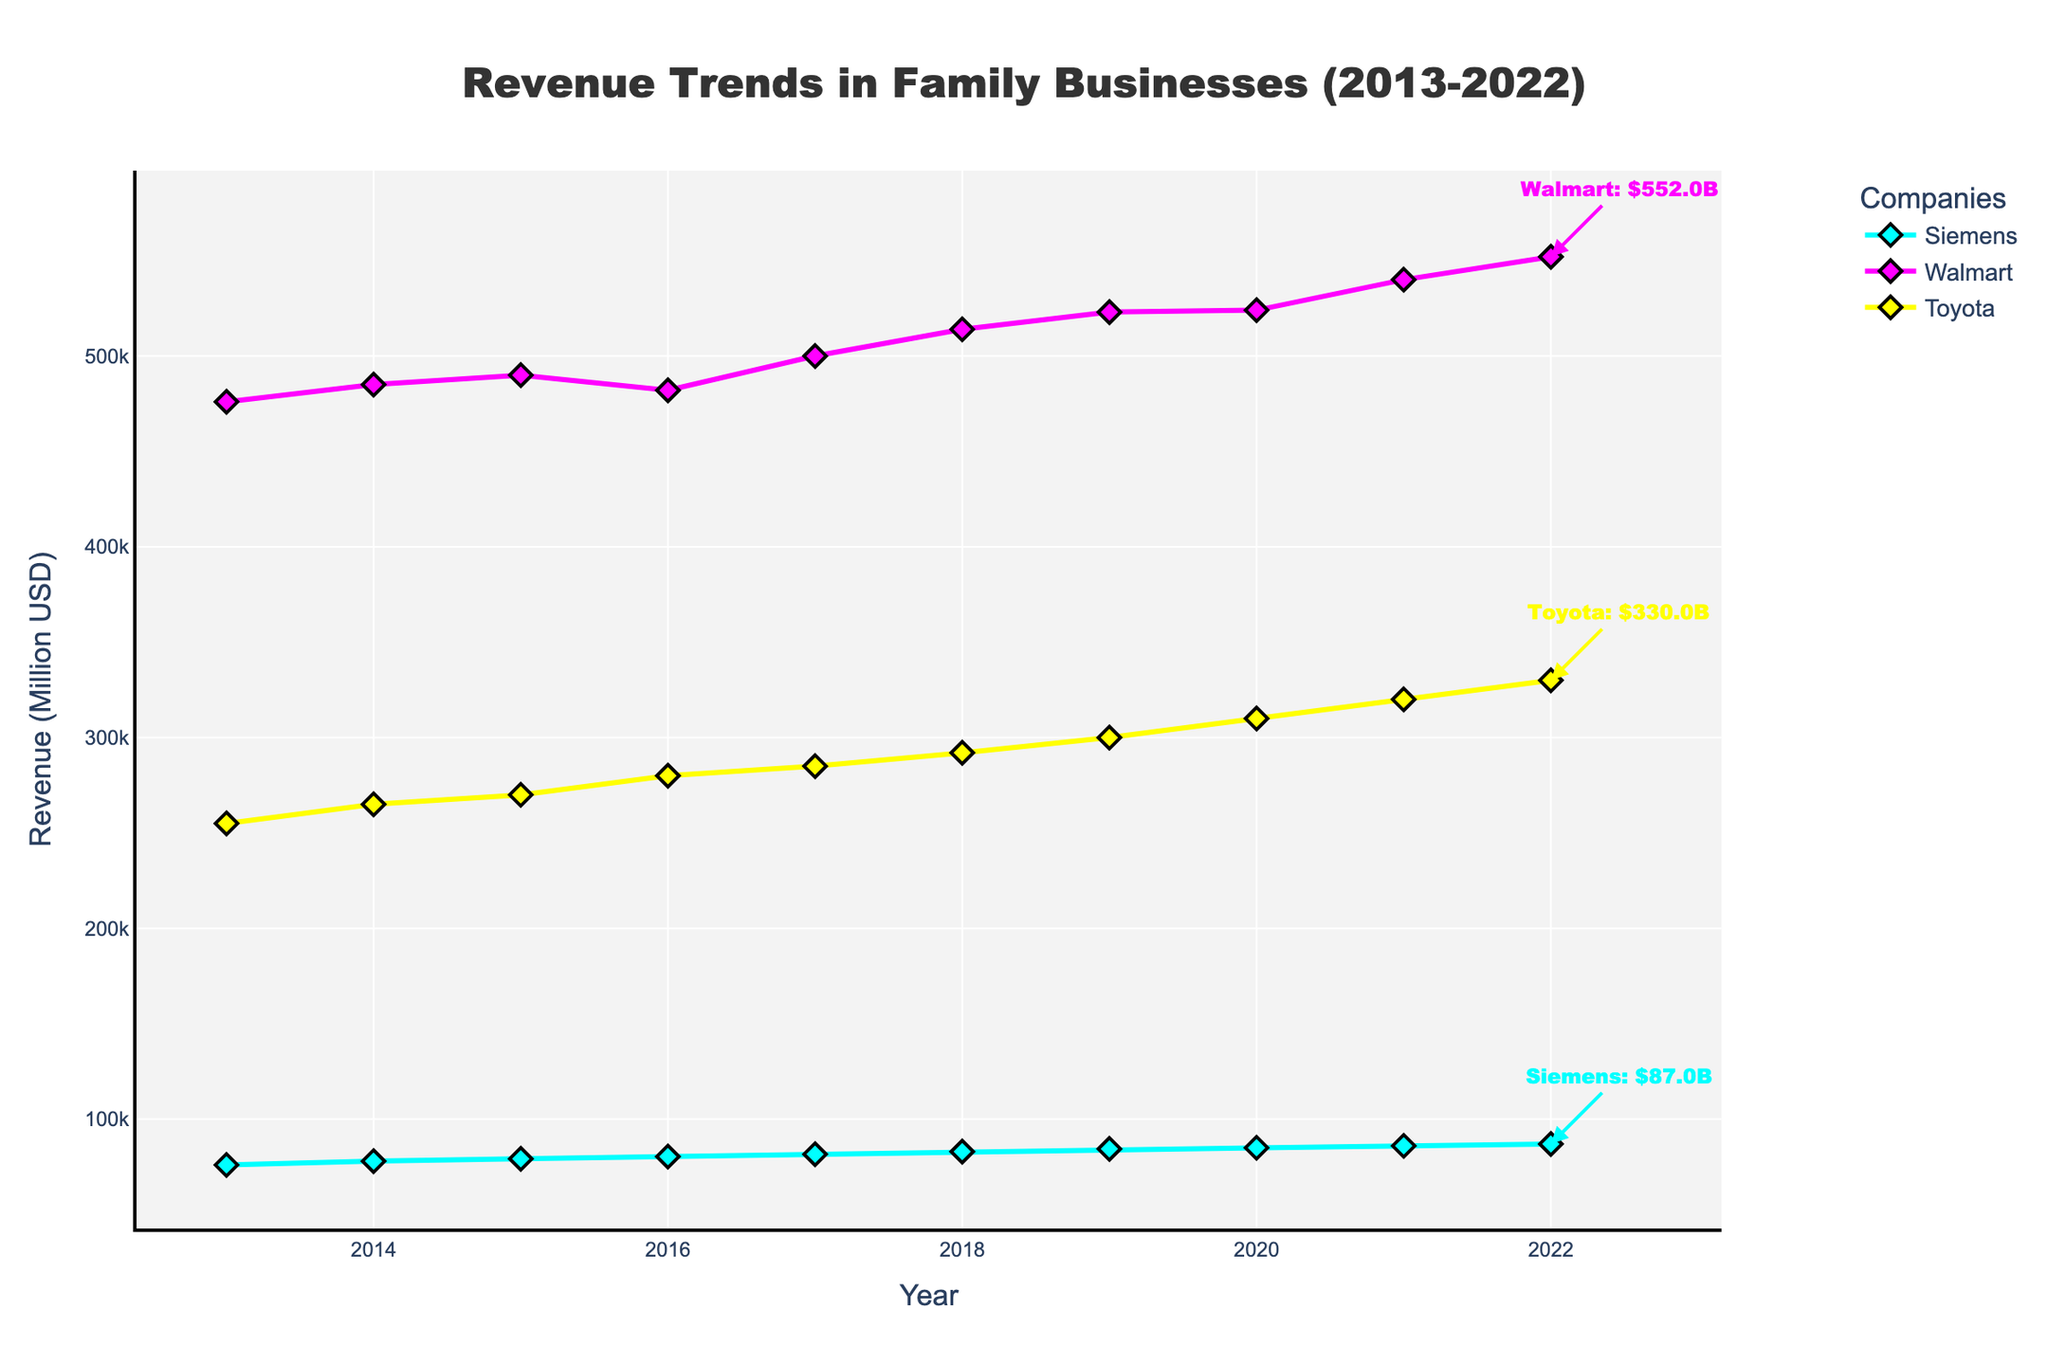What is the title of the plot? The title of the plot is written prominently at the top of the figure.
Answer: Revenue Trends in Family Businesses (2013-2022) Which company in the Manufacturing industry is represented in the plot? The plot uses color coding for different companies, and the annotation shows "Siemens" with revenue values linked to the corresponding color.
Answer: Siemens How many companies' data are included in the plot? By looking at the legend and the different lines on the plot, we can see three companies are represented.
Answer: 3 What was the revenue of Walmart in 2015? Locate the data point along the curve for Walmart at the year 2015 on the x-axis; the corresponding y-value gives the revenue.
Answer: $490,000 million Which company had the highest revenue in 2022? Compare the annotations or the endpoints of the lines at 2022; Walmart has the highest revenue.
Answer: Walmart How did Siemens' revenue change from 2013 to 2022? By looking at Siemens' line from 2013 to 2022, you can see it gradually increases. Calculate the difference between the 2022 and 2013 values: 87000 - 76000 = 11000.
Answer: Increased by $11,000 million Which company experienced the largest revenue growth between 2013 and 2022? Calculate the difference in revenue for each company from 2013 to 2022:
- Siemens: 87000 - 76000 = 11000
- Walmart: 552000 - 476000 = 76000
- Toyota: 330000 - 255000 = 75000
Walmart shows the largest increase.
Answer: Walmart Did any company have a year where its revenue decreased from the previous year? Identify points where the line for a company drops from one year to the next. For Walmart, there is a decrease between 2015 and 2016.
Answer: Yes, Walmart in 2016 Compare the revenue trends of Toyota and Siemens over the decade. Both trends can be observed by comparing their respective lines over the years:
- Toyota consistently increases.
- Siemens shows a consistent but slower increase.
Toyota has a steeper growth curve than Siemens.
Answer: Toyota increased faster than Siemens In what year did Walmart reach a $500,000 million revenue? Locate the point on the Walmart line where the revenue reaches $500,000 million; this happens in 2017.
Answer: 2017 